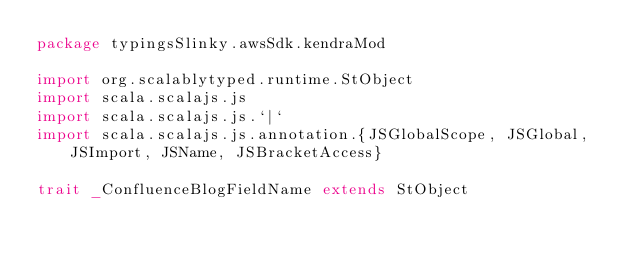Convert code to text. <code><loc_0><loc_0><loc_500><loc_500><_Scala_>package typingsSlinky.awsSdk.kendraMod

import org.scalablytyped.runtime.StObject
import scala.scalajs.js
import scala.scalajs.js.`|`
import scala.scalajs.js.annotation.{JSGlobalScope, JSGlobal, JSImport, JSName, JSBracketAccess}

trait _ConfluenceBlogFieldName extends StObject
</code> 